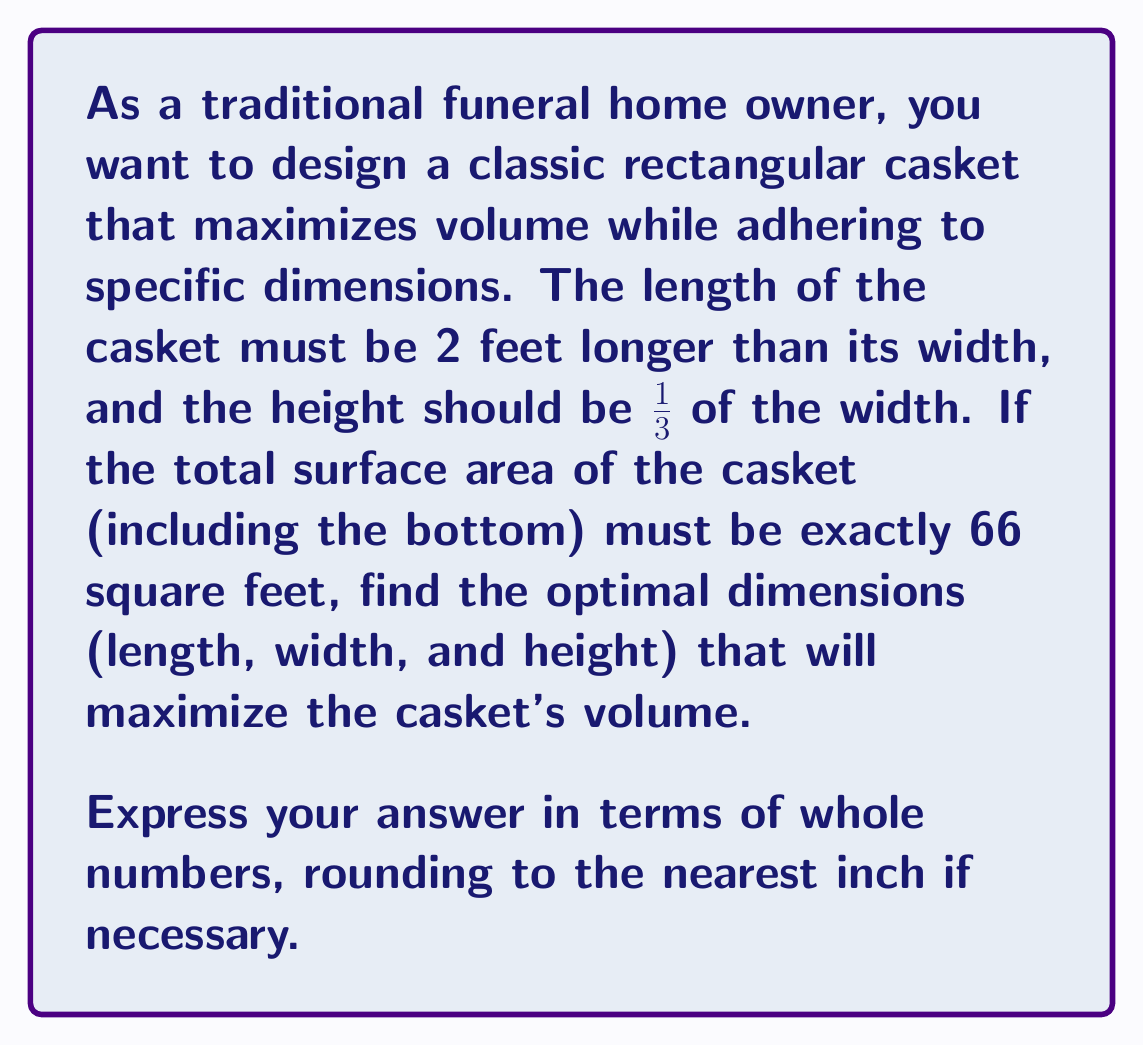Show me your answer to this math problem. Let's approach this step-by-step:

1) Let $w$ be the width of the casket. Then:
   Length = $w + 2$
   Height = $\frac{w}{3}$

2) The surface area formula for a rectangular prism is:
   $SA = 2lw + 2lh + 2wh$

3) Substituting our expressions:
   $66 = 2(w+2)w + 2(w+2)(\frac{w}{3}) + 2w(\frac{w}{3})$

4) Simplifying:
   $66 = 2w^2 + 4w + \frac{2w^2}{3} + \frac{4w}{3} + \frac{2w^2}{3}$
   $66 = 2w^2 + 4w + w^2 + \frac{4w}{3}$
   $66 = 3w^2 + 4w + \frac{4w}{3}$
   $66 = 3w^2 + \frac{16w}{3}$

5) Multiplying both sides by 3:
   $198 = 9w^2 + 16w$

6) Rearranging to standard quadratic form:
   $9w^2 + 16w - 198 = 0$

7) Using the quadratic formula: $w = \frac{-b \pm \sqrt{b^2 - 4ac}}{2a}$
   $w = \frac{-16 \pm \sqrt{16^2 - 4(9)(-198)}}{2(9)}$
   $w = \frac{-16 \pm \sqrt{256 + 7128}}{18}$
   $w = \frac{-16 \pm \sqrt{7384}}{18}$
   $w = \frac{-16 \pm 85.93}{18}$

8) Taking the positive root:
   $w = \frac{-16 + 85.93}{18} = 3.88$ feet

9) Rounding to the nearest inch: $w = 3$ feet 11 inches

10) Calculating other dimensions:
    Length = $3.88 + 2 = 5.88$ feet ≈ 5 feet 11 inches
    Height = $3.88/3 = 1.29$ feet ≈ 1 foot 3 inches

11) The volume of the casket would be:
    $V = lwh = 5.88 * 3.88 * 1.29 = 29.45$ cubic feet
Answer: The optimal dimensions for the casket are:
Length: 5 feet 11 inches
Width: 3 feet 11 inches
Height: 1 foot 3 inches 